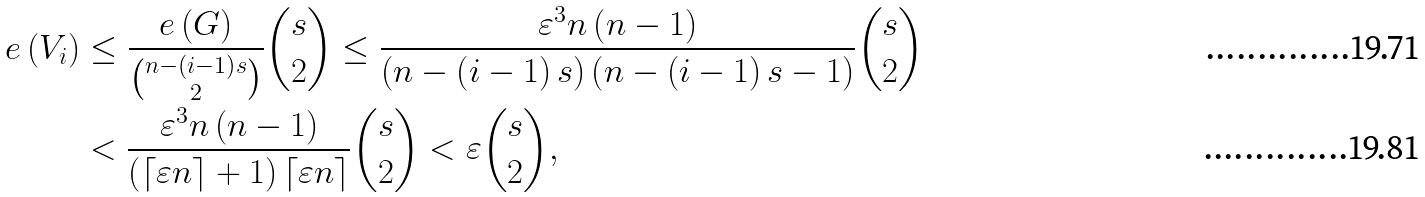Convert formula to latex. <formula><loc_0><loc_0><loc_500><loc_500>e \left ( V _ { i } \right ) & \leq \frac { e \left ( G \right ) } { \binom { n - \left ( i - 1 \right ) s } { 2 } } \binom { s } { 2 } \leq \frac { \varepsilon ^ { 3 } n \left ( n - 1 \right ) } { \left ( n - \left ( i - 1 \right ) s \right ) \left ( n - \left ( i - 1 \right ) s - 1 \right ) } \binom { s } { 2 } \\ & < \frac { \varepsilon ^ { 3 } n \left ( n - 1 \right ) } { \left ( \left \lceil \varepsilon n \right \rceil + 1 \right ) \left \lceil \varepsilon n \right \rceil } \binom { s } { 2 } < \varepsilon \binom { s } { 2 } ,</formula> 